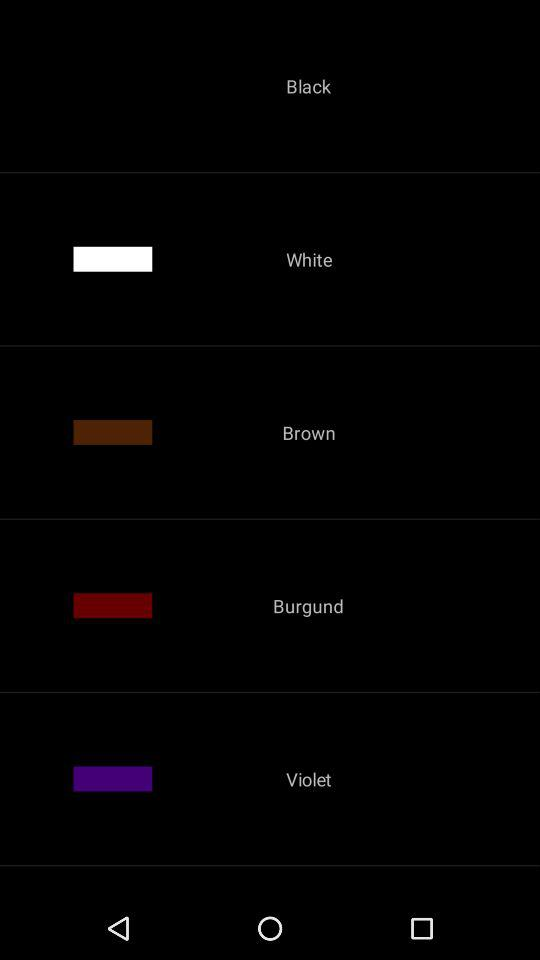How many color options are there?
Answer the question using a single word or phrase. 5 